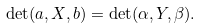<formula> <loc_0><loc_0><loc_500><loc_500>\det ( a , X , b ) = \det ( \alpha , Y , \beta ) .</formula> 